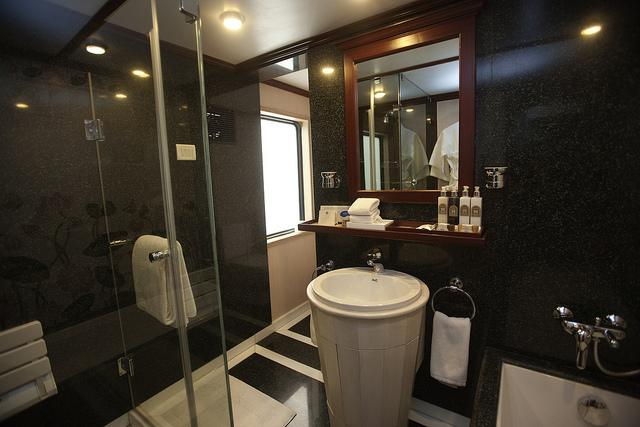What shape is the mirror hanging on the wall with some wooden planks?

Choices:
A) circle
B) rectangle
C) square
D) oval rectangle 